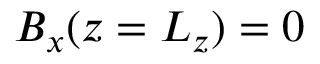Convert formula to latex. <formula><loc_0><loc_0><loc_500><loc_500>B _ { x } ( z = L _ { z } ) = 0</formula> 